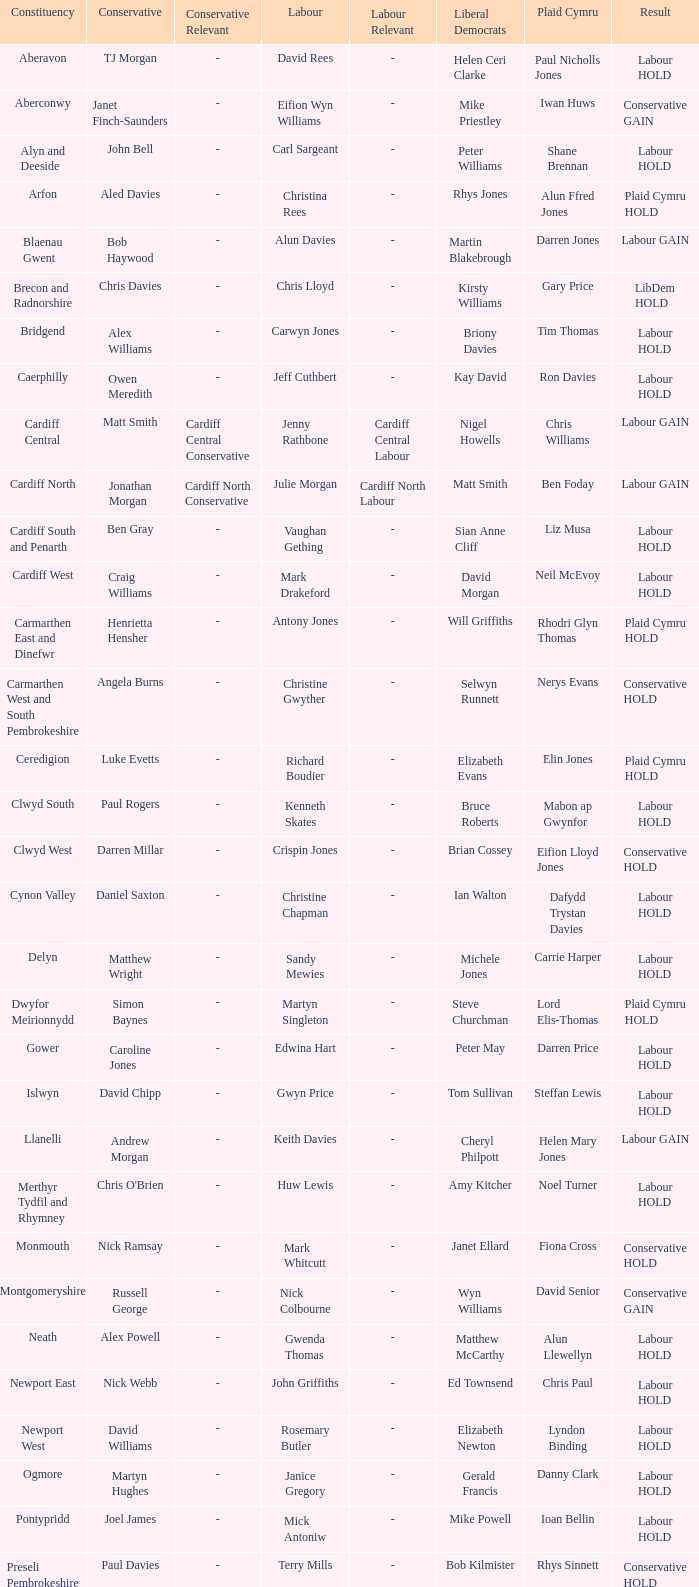What constituency does the Conservative Darren Millar belong to? Clwyd West. 